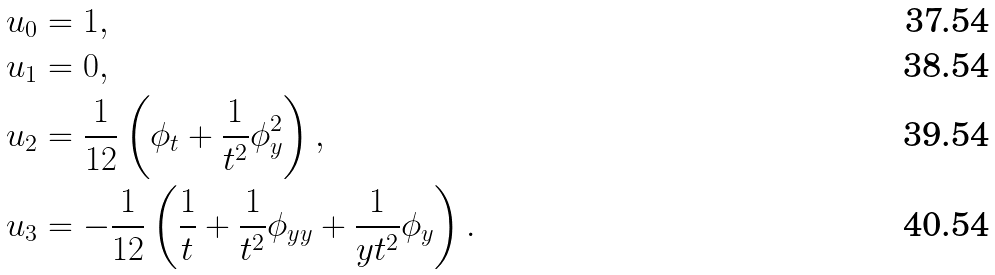<formula> <loc_0><loc_0><loc_500><loc_500>u _ { 0 } & = 1 , \\ u _ { 1 } & = 0 , \\ u _ { 2 } & = \frac { 1 } { 1 2 } \left ( \phi _ { t } + \frac { 1 } { t ^ { 2 } } \phi _ { y } ^ { 2 } \right ) , \\ u _ { 3 } & = - \frac { 1 } { 1 2 } \left ( \frac { 1 } { t } + \frac { 1 } { t ^ { 2 } } \phi _ { y y } + \frac { 1 } { y t ^ { 2 } } \phi _ { y } \right ) .</formula> 